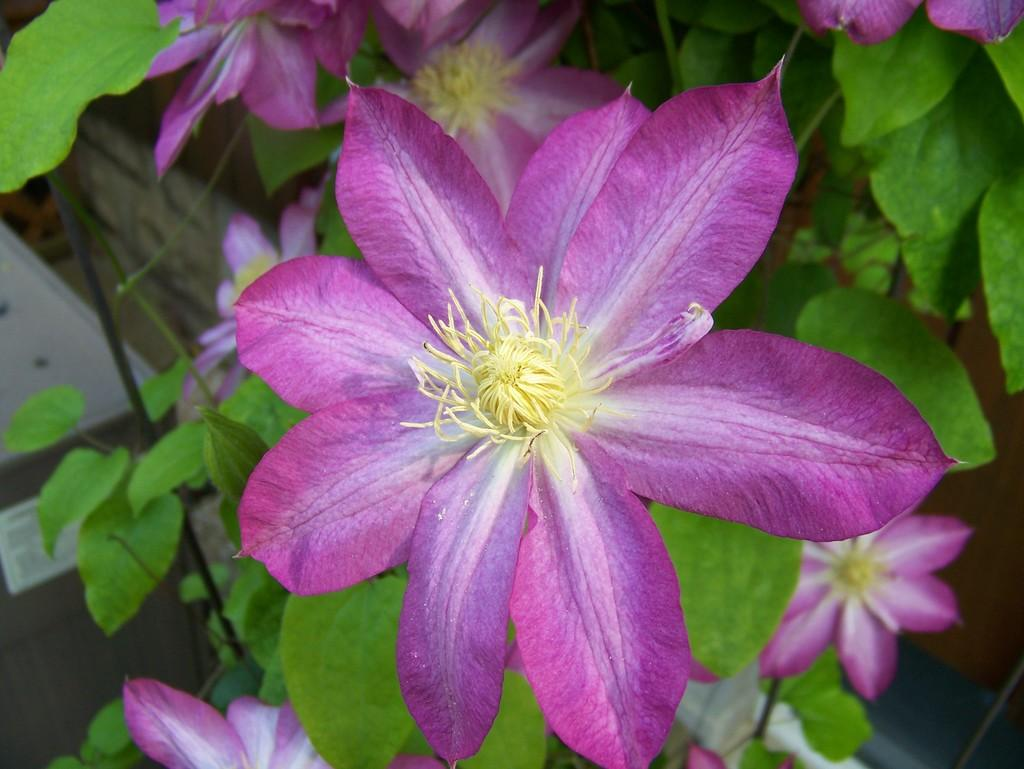What type of flower is present in the image? There is a purple color flower in the image. Is the flower part of a larger plant? Yes, the flower is part of a plant. How would you describe the background of the image? The background of the image is slightly blurred. Are there any other flowers visible in the image? Yes, there are a few more purple color flowers visible in the background. Can you see any dolls interacting with the flowers in the image? There are no dolls present in the image, and therefore no interaction with the flowers can be observed. 